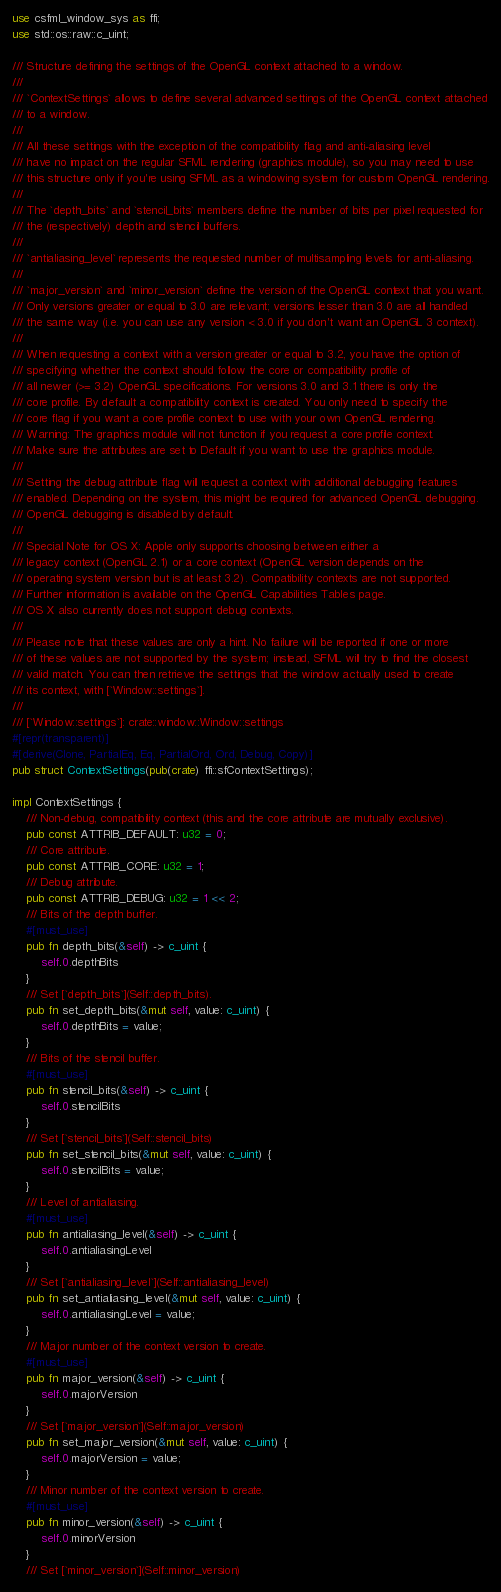<code> <loc_0><loc_0><loc_500><loc_500><_Rust_>use csfml_window_sys as ffi;
use std::os::raw::c_uint;

/// Structure defining the settings of the OpenGL context attached to a window.
///
/// `ContextSettings` allows to define several advanced settings of the OpenGL context attached
/// to a window.
///
/// All these settings with the exception of the compatibility flag and anti-aliasing level
/// have no impact on the regular SFML rendering (graphics module), so you may need to use
/// this structure only if you're using SFML as a windowing system for custom OpenGL rendering.
///
/// The `depth_bits` and `stencil_bits` members define the number of bits per pixel requested for
/// the (respectively) depth and stencil buffers.
///
/// `antialiasing_level` represents the requested number of multisampling levels for anti-aliasing.
///
/// `major_version` and `minor_version` define the version of the OpenGL context that you want.
/// Only versions greater or equal to 3.0 are relevant; versions lesser than 3.0 are all handled
/// the same way (i.e. you can use any version < 3.0 if you don't want an OpenGL 3 context).
///
/// When requesting a context with a version greater or equal to 3.2, you have the option of
/// specifying whether the context should follow the core or compatibility profile of
/// all newer (>= 3.2) OpenGL specifications. For versions 3.0 and 3.1 there is only the
/// core profile. By default a compatibility context is created. You only need to specify the
/// core flag if you want a core profile context to use with your own OpenGL rendering.
/// Warning: The graphics module will not function if you request a core profile context.
/// Make sure the attributes are set to Default if you want to use the graphics module.
///
/// Setting the debug attribute flag will request a context with additional debugging features
/// enabled. Depending on the system, this might be required for advanced OpenGL debugging.
/// OpenGL debugging is disabled by default.
///
/// Special Note for OS X: Apple only supports choosing between either a
/// legacy context (OpenGL 2.1) or a core context (OpenGL version depends on the
/// operating system version but is at least 3.2). Compatibility contexts are not supported.
/// Further information is available on the OpenGL Capabilities Tables page.
/// OS X also currently does not support debug contexts.
///
/// Please note that these values are only a hint. No failure will be reported if one or more
/// of these values are not supported by the system; instead, SFML will try to find the closest
/// valid match. You can then retrieve the settings that the window actually used to create
/// its context, with [`Window::settings`].
///
/// [`Window::settings`]: crate::window::Window::settings
#[repr(transparent)]
#[derive(Clone, PartialEq, Eq, PartialOrd, Ord, Debug, Copy)]
pub struct ContextSettings(pub(crate) ffi::sfContextSettings);

impl ContextSettings {
    /// Non-debug, compatibility context (this and the core attribute are mutually exclusive).
    pub const ATTRIB_DEFAULT: u32 = 0;
    /// Core attribute.
    pub const ATTRIB_CORE: u32 = 1;
    /// Debug attribute.
    pub const ATTRIB_DEBUG: u32 = 1 << 2;
    /// Bits of the depth buffer.
    #[must_use]
    pub fn depth_bits(&self) -> c_uint {
        self.0.depthBits
    }
    /// Set [`depth_bits`](Self::depth_bits).
    pub fn set_depth_bits(&mut self, value: c_uint) {
        self.0.depthBits = value;
    }
    /// Bits of the stencil buffer.
    #[must_use]
    pub fn stencil_bits(&self) -> c_uint {
        self.0.stencilBits
    }
    /// Set [`stencil_bits`](Self::stencil_bits)
    pub fn set_stencil_bits(&mut self, value: c_uint) {
        self.0.stencilBits = value;
    }
    /// Level of antialiasing.
    #[must_use]
    pub fn antialiasing_level(&self) -> c_uint {
        self.0.antialiasingLevel
    }
    /// Set [`antialiasing_level`](Self::antialiasing_level)
    pub fn set_antialiasing_level(&mut self, value: c_uint) {
        self.0.antialiasingLevel = value;
    }
    /// Major number of the context version to create.
    #[must_use]
    pub fn major_version(&self) -> c_uint {
        self.0.majorVersion
    }
    /// Set [`major_version`](Self::major_version)
    pub fn set_major_version(&mut self, value: c_uint) {
        self.0.majorVersion = value;
    }
    /// Minor number of the context version to create.
    #[must_use]
    pub fn minor_version(&self) -> c_uint {
        self.0.minorVersion
    }
    /// Set [`minor_version`](Self::minor_version)</code> 